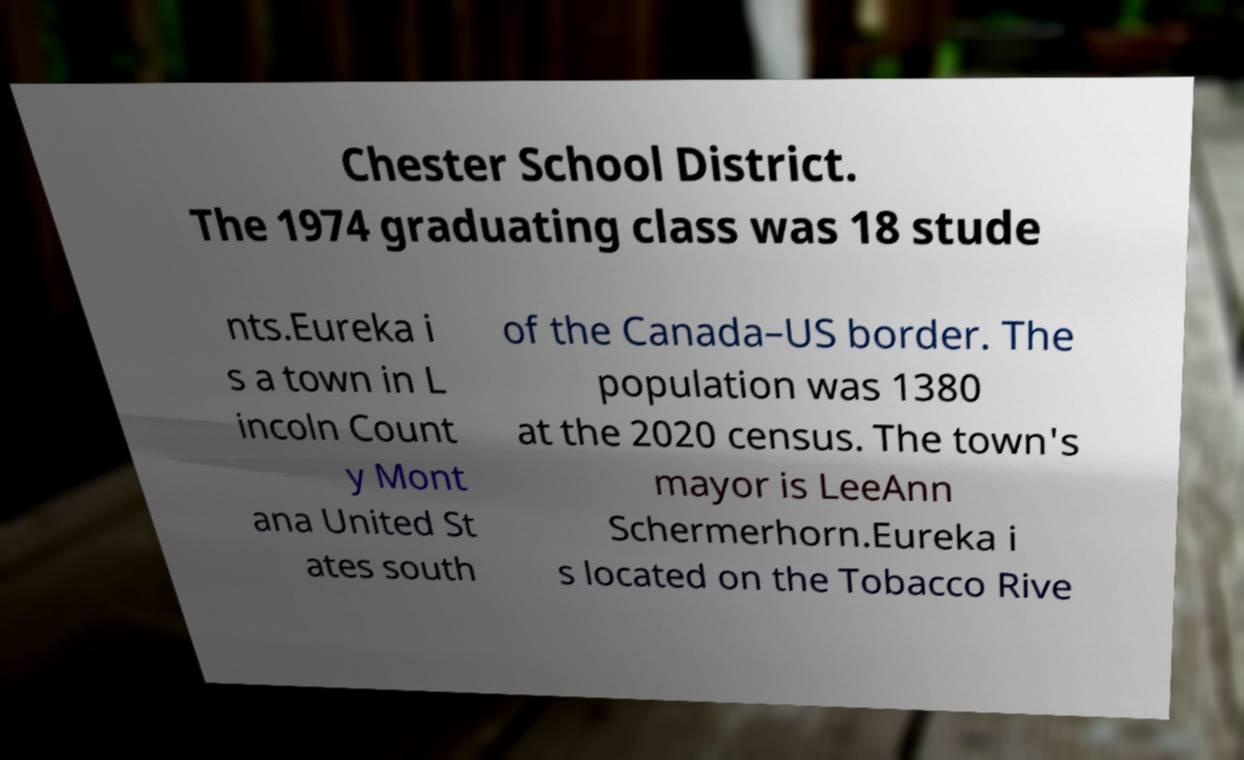Could you assist in decoding the text presented in this image and type it out clearly? Chester School District. The 1974 graduating class was 18 stude nts.Eureka i s a town in L incoln Count y Mont ana United St ates south of the Canada–US border. The population was 1380 at the 2020 census. The town's mayor is LeeAnn Schermerhorn.Eureka i s located on the Tobacco Rive 